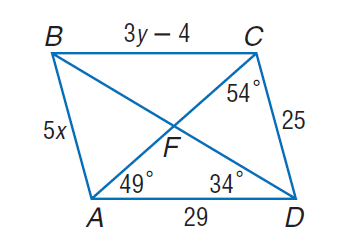Answer the mathemtical geometry problem and directly provide the correct option letter.
Question: Use parallelogram A B C D to find y.
Choices: A: 11 B: 34 C: 49 D: 54 A 